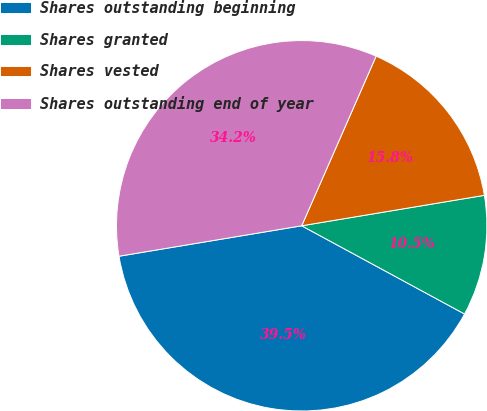Convert chart. <chart><loc_0><loc_0><loc_500><loc_500><pie_chart><fcel>Shares outstanding beginning<fcel>Shares granted<fcel>Shares vested<fcel>Shares outstanding end of year<nl><fcel>39.47%<fcel>10.53%<fcel>15.79%<fcel>34.21%<nl></chart> 